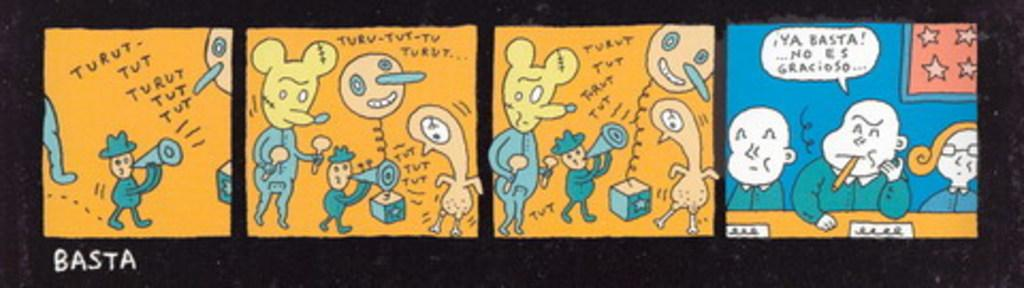<image>
Relay a brief, clear account of the picture shown. a comic strip with Basta written on the bottom left 